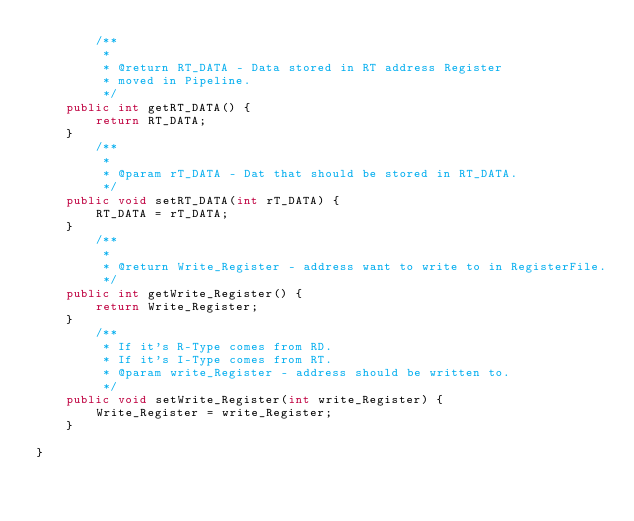Convert code to text. <code><loc_0><loc_0><loc_500><loc_500><_Java_>        /**
         * 
         * @return RT_DATA - Data stored in RT address Register 
         * moved in Pipeline.
         */
	public int getRT_DATA() {
		return RT_DATA;
	}
        /**
         * 
         * @param rT_DATA - Dat that should be stored in RT_DATA.
         */
	public void setRT_DATA(int rT_DATA) {
		RT_DATA = rT_DATA;
	}
        /**
         * 
         * @return Write_Register - address want to write to in RegisterFile.
         */
	public int getWrite_Register() {
		return Write_Register;
	}
        /**
         * If it's R-Type comes from RD.
         * If it's I-Type comes from RT.
         * @param write_Register - address should be written to.  
         */
	public void setWrite_Register(int write_Register) {
		Write_Register = write_Register;
	}
	
}</code> 